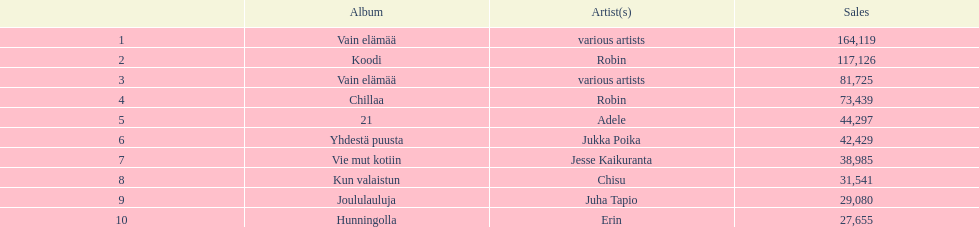What are all the album titles? Vain elämää, Koodi, Vain elämää, Chillaa, 21, Yhdestä puusta, Vie mut kotiin, Kun valaistun, Joululauluja, Hunningolla. Which artists were on the albums? Various artists, robin, various artists, robin, adele, jukka poika, jesse kaikuranta, chisu, juha tapio, erin. Along with chillaa, which other album featured robin? Koodi. 